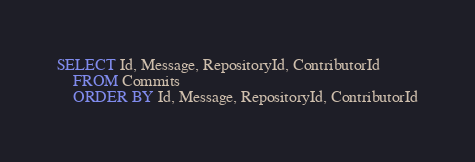Convert code to text. <code><loc_0><loc_0><loc_500><loc_500><_SQL_>SELECT Id, Message, RepositoryId, ContributorId
	FROM Commits
	ORDER BY Id, Message, RepositoryId, ContributorId</code> 